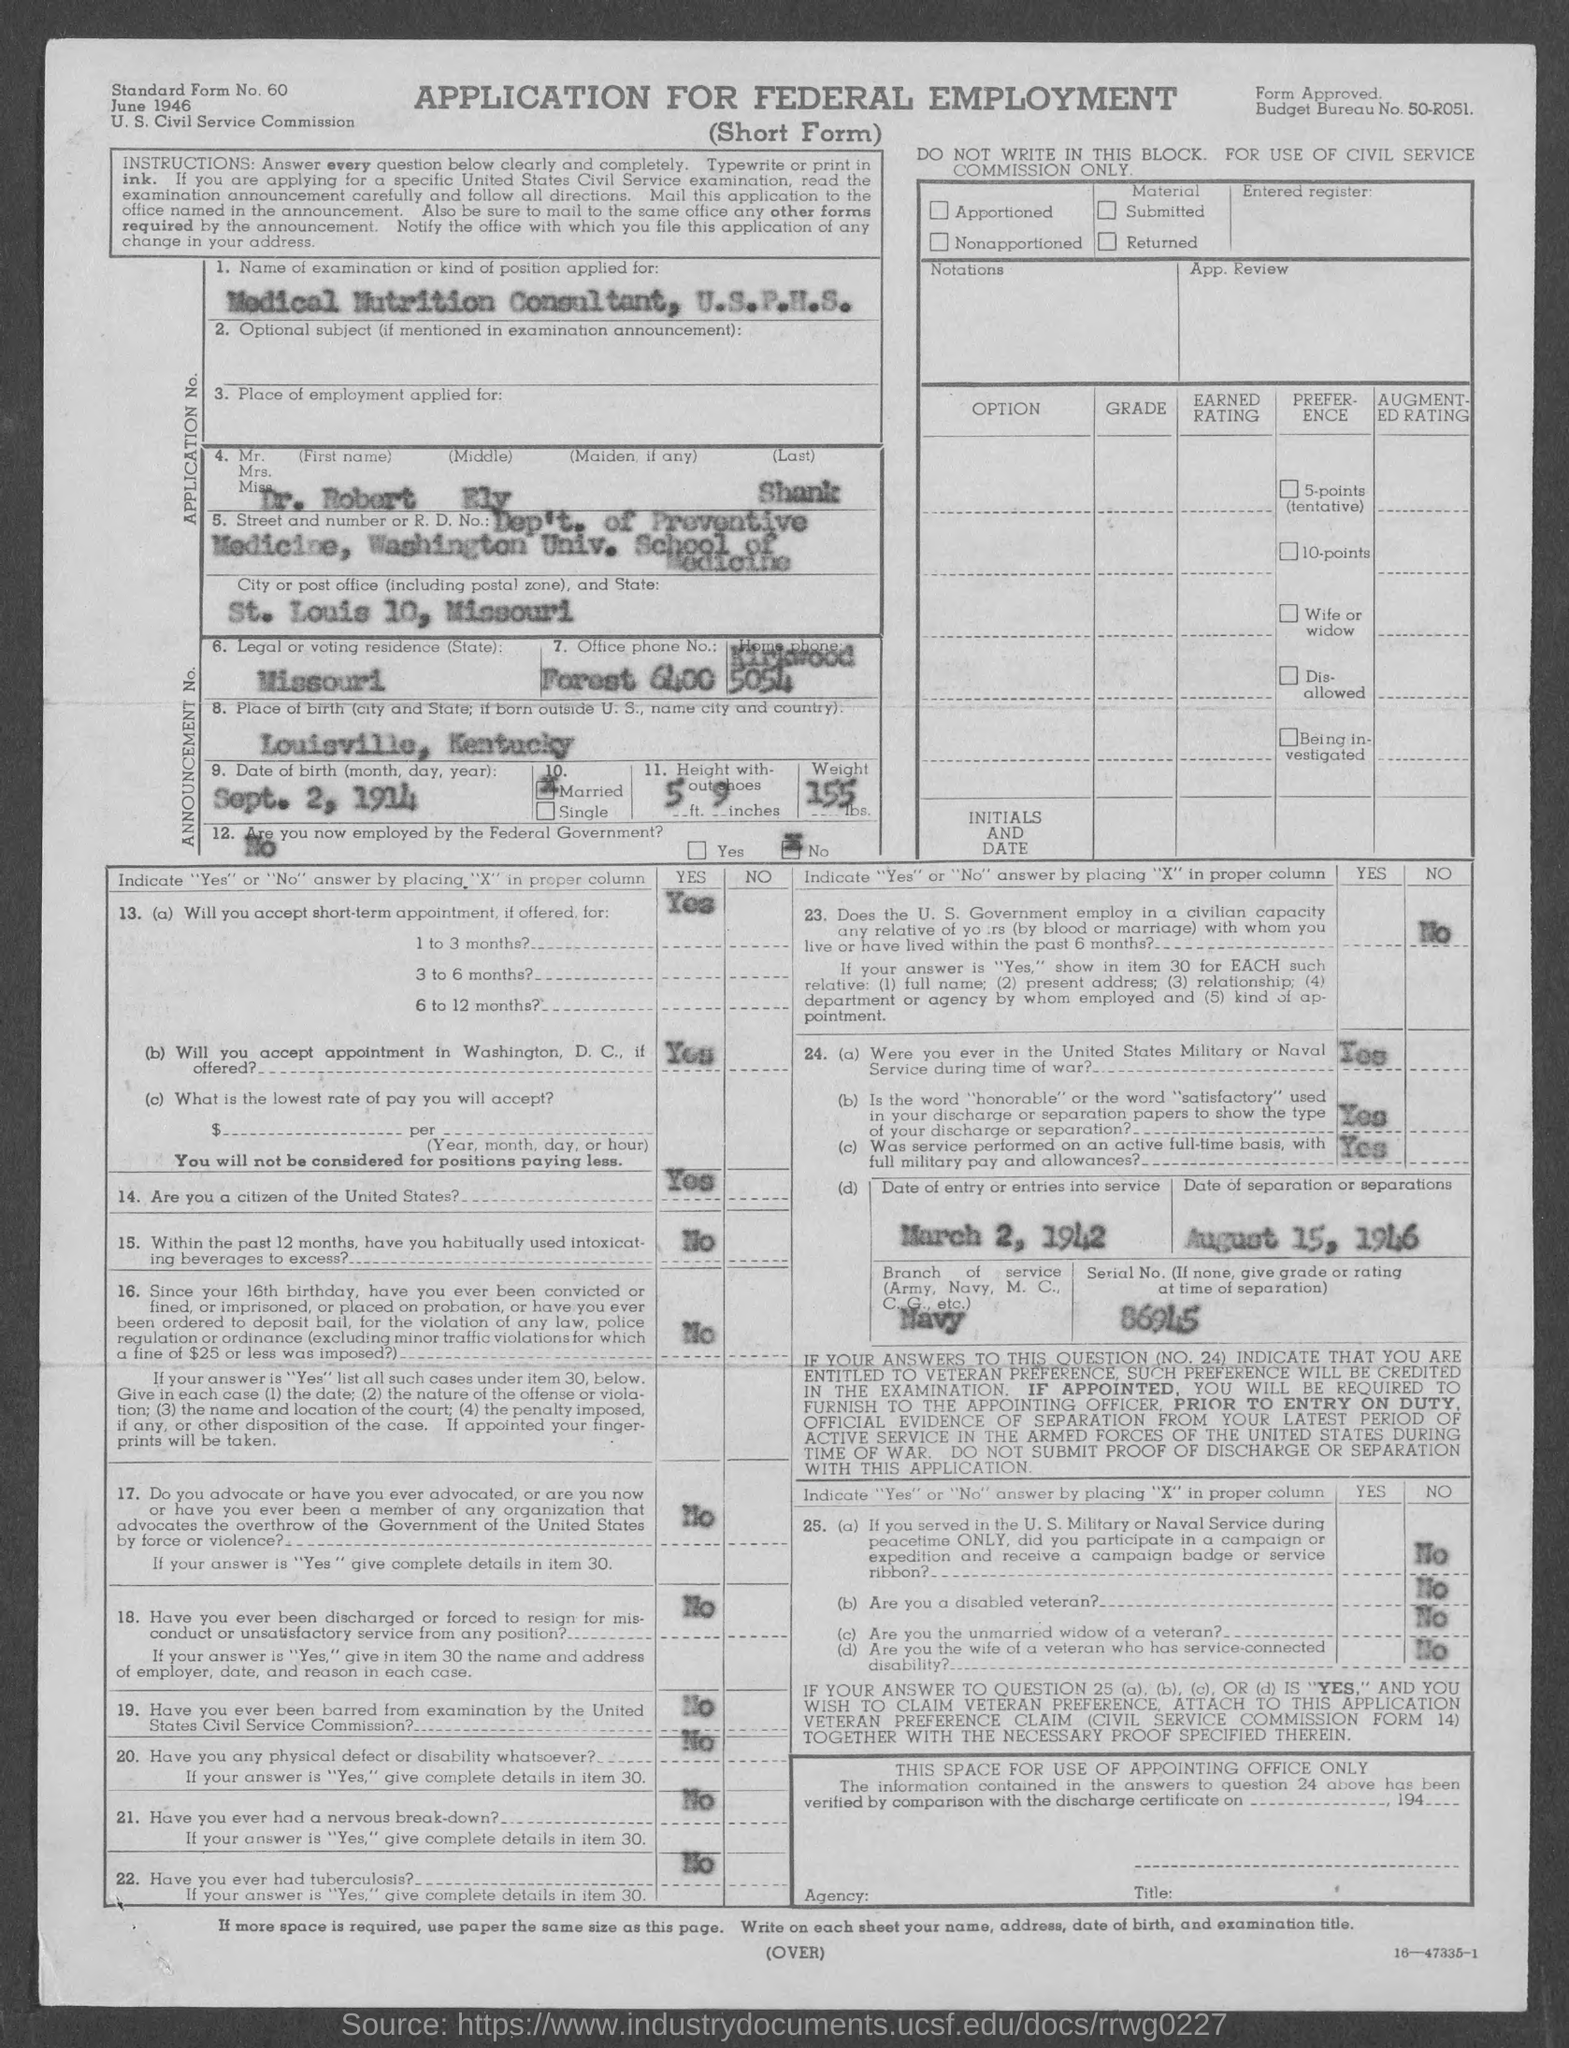What is the budget bureau no.?
Your response must be concise. 50-R051. What is the standard form no.?
Ensure brevity in your answer.  60. What is the birth place of applicant ?
Provide a short and direct response. Louisville, kentucky. What is the date of birth of applicant ?
Offer a very short reply. Sept. 2, 1914. Is the applicant married ?
Give a very brief answer. Yes. What is the weight of the applicant ?
Provide a succinct answer. 155 lbs. Is the applicant currently employed by federal government ?
Your response must be concise. No. What is the date of entry or entries into service?
Keep it short and to the point. March 2, 1942. What is the serial no. ( if none, give grade or rating at time of separation )?
Give a very brief answer. 86945. 